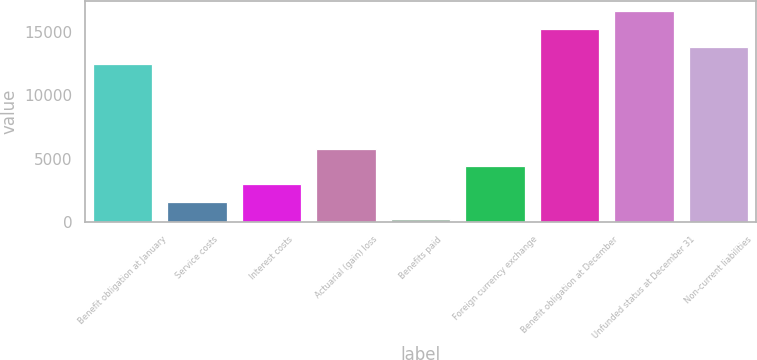Convert chart. <chart><loc_0><loc_0><loc_500><loc_500><bar_chart><fcel>Benefit obligation at January<fcel>Service costs<fcel>Interest costs<fcel>Actuarial (gain) loss<fcel>Benefits paid<fcel>Foreign currency exchange<fcel>Benefit obligation at December<fcel>Unfunded status at December 31<fcel>Non-current liabilities<nl><fcel>12461<fcel>1580.6<fcel>2984.2<fcel>5791.4<fcel>177<fcel>4387.8<fcel>15268.2<fcel>16671.8<fcel>13864.6<nl></chart> 